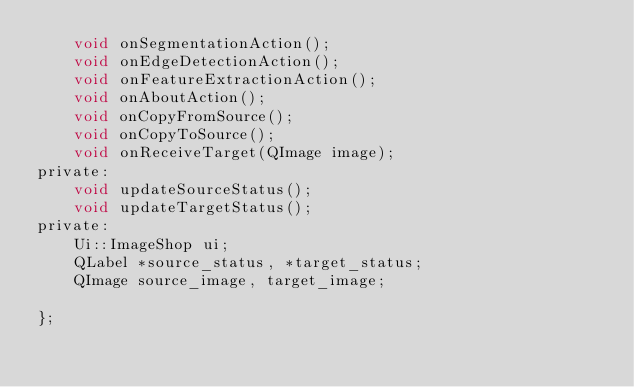<code> <loc_0><loc_0><loc_500><loc_500><_C_>    void onSegmentationAction();
    void onEdgeDetectionAction();
    void onFeatureExtractionAction();
    void onAboutAction();
    void onCopyFromSource();
    void onCopyToSource();
    void onReceiveTarget(QImage image);
private:
    void updateSourceStatus();
    void updateTargetStatus();
private:
    Ui::ImageShop ui;
    QLabel *source_status, *target_status;
    QImage source_image, target_image;

};
</code> 